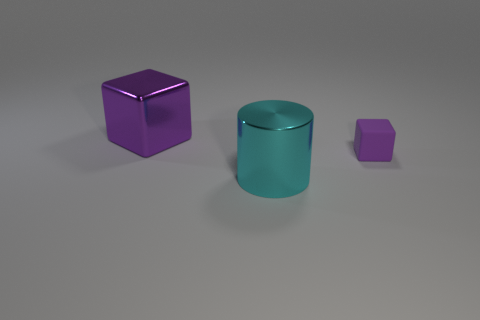Subtract all yellow cubes. Subtract all red spheres. How many cubes are left? 2 Add 1 cyan metal things. How many objects exist? 4 Subtract all cylinders. How many objects are left? 2 Subtract 0 gray cubes. How many objects are left? 3 Subtract all big matte objects. Subtract all big things. How many objects are left? 1 Add 2 big cyan objects. How many big cyan objects are left? 3 Add 1 large purple things. How many large purple things exist? 2 